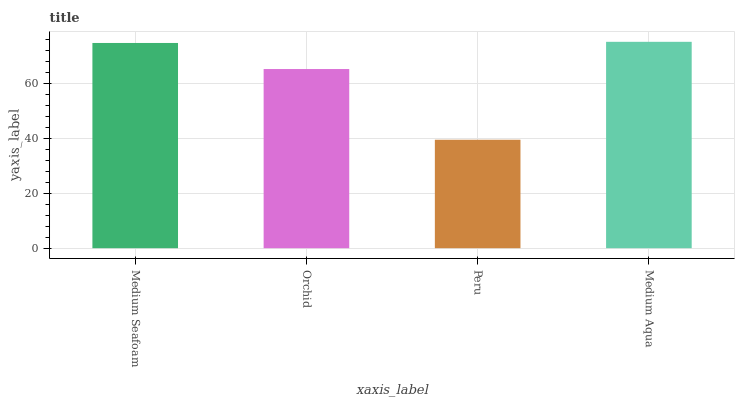Is Peru the minimum?
Answer yes or no. Yes. Is Medium Aqua the maximum?
Answer yes or no. Yes. Is Orchid the minimum?
Answer yes or no. No. Is Orchid the maximum?
Answer yes or no. No. Is Medium Seafoam greater than Orchid?
Answer yes or no. Yes. Is Orchid less than Medium Seafoam?
Answer yes or no. Yes. Is Orchid greater than Medium Seafoam?
Answer yes or no. No. Is Medium Seafoam less than Orchid?
Answer yes or no. No. Is Medium Seafoam the high median?
Answer yes or no. Yes. Is Orchid the low median?
Answer yes or no. Yes. Is Peru the high median?
Answer yes or no. No. Is Medium Seafoam the low median?
Answer yes or no. No. 